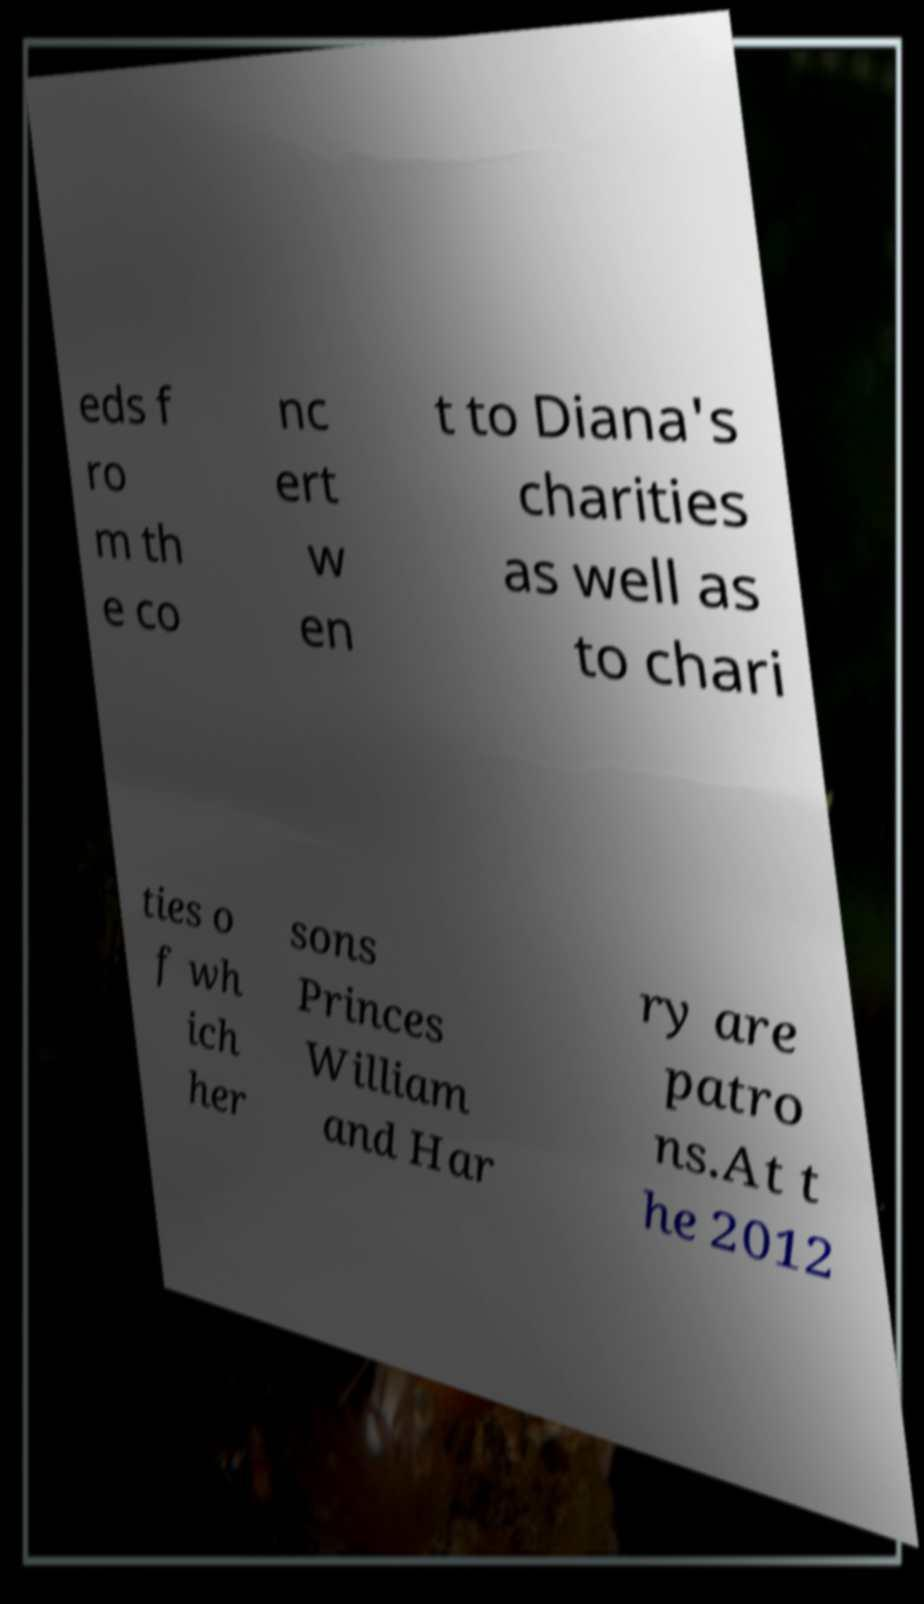There's text embedded in this image that I need extracted. Can you transcribe it verbatim? eds f ro m th e co nc ert w en t to Diana's charities as well as to chari ties o f wh ich her sons Princes William and Har ry are patro ns.At t he 2012 